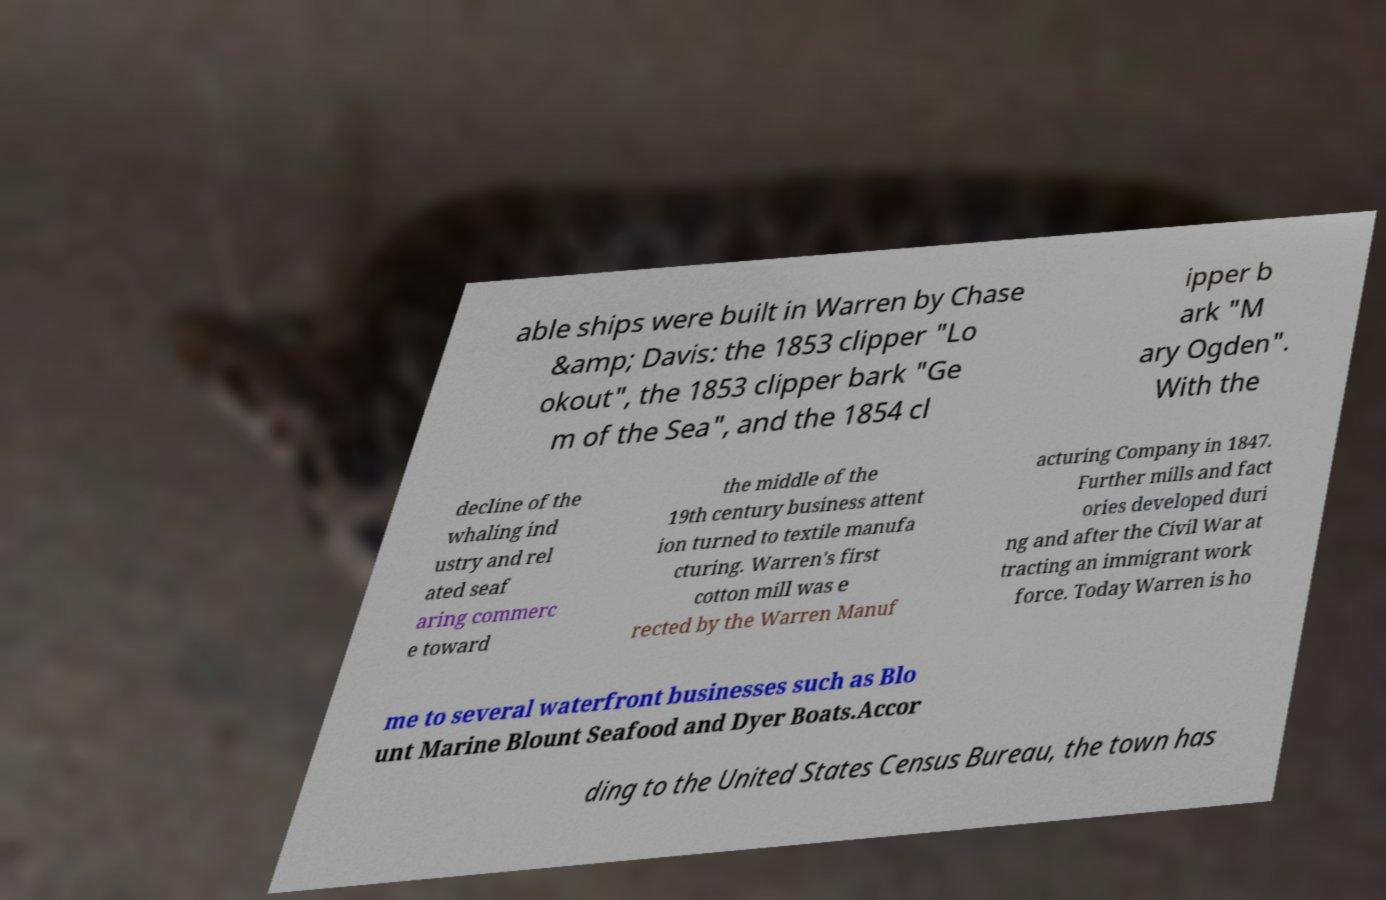Please identify and transcribe the text found in this image. able ships were built in Warren by Chase &amp; Davis: the 1853 clipper "Lo okout", the 1853 clipper bark "Ge m of the Sea", and the 1854 cl ipper b ark "M ary Ogden". With the decline of the whaling ind ustry and rel ated seaf aring commerc e toward the middle of the 19th century business attent ion turned to textile manufa cturing. Warren's first cotton mill was e rected by the Warren Manuf acturing Company in 1847. Further mills and fact ories developed duri ng and after the Civil War at tracting an immigrant work force. Today Warren is ho me to several waterfront businesses such as Blo unt Marine Blount Seafood and Dyer Boats.Accor ding to the United States Census Bureau, the town has 